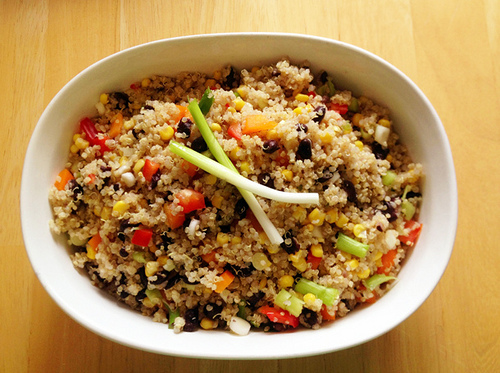<image>
Is the bule on the table? Yes. Looking at the image, I can see the bule is positioned on top of the table, with the table providing support. Where is the onion in relation to the bowl? Is it on the bowl? No. The onion is not positioned on the bowl. They may be near each other, but the onion is not supported by or resting on top of the bowl. 